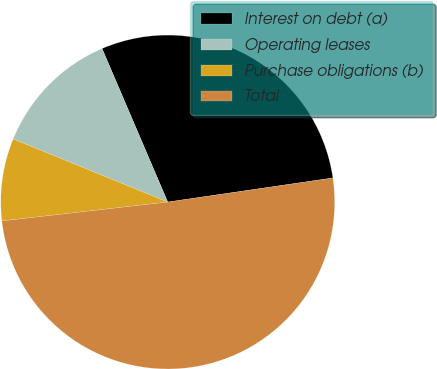Convert chart. <chart><loc_0><loc_0><loc_500><loc_500><pie_chart><fcel>Interest on debt (a)<fcel>Operating leases<fcel>Purchase obligations (b)<fcel>Total<nl><fcel>29.13%<fcel>12.4%<fcel>7.97%<fcel>50.5%<nl></chart> 